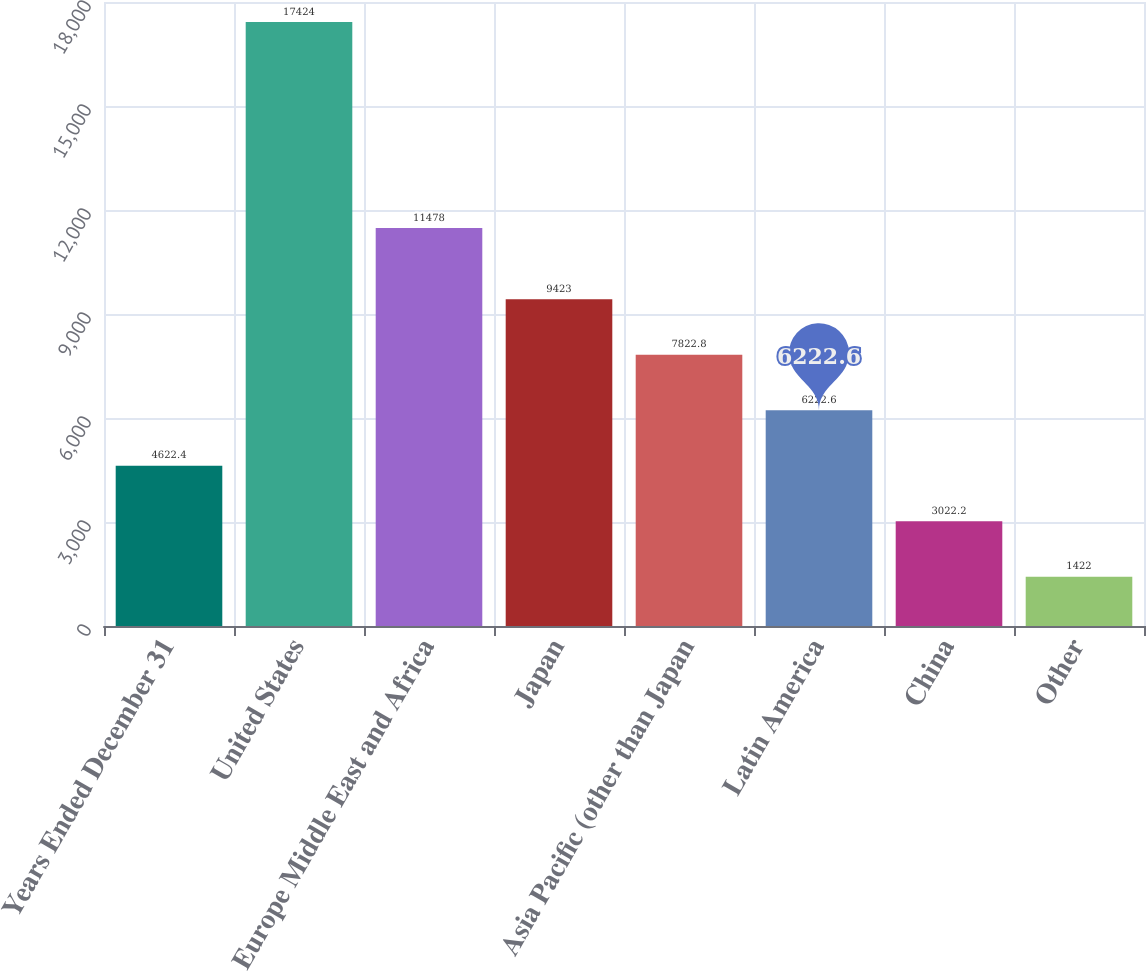Convert chart to OTSL. <chart><loc_0><loc_0><loc_500><loc_500><bar_chart><fcel>Years Ended December 31<fcel>United States<fcel>Europe Middle East and Africa<fcel>Japan<fcel>Asia Pacific (other than Japan<fcel>Latin America<fcel>China<fcel>Other<nl><fcel>4622.4<fcel>17424<fcel>11478<fcel>9423<fcel>7822.8<fcel>6222.6<fcel>3022.2<fcel>1422<nl></chart> 